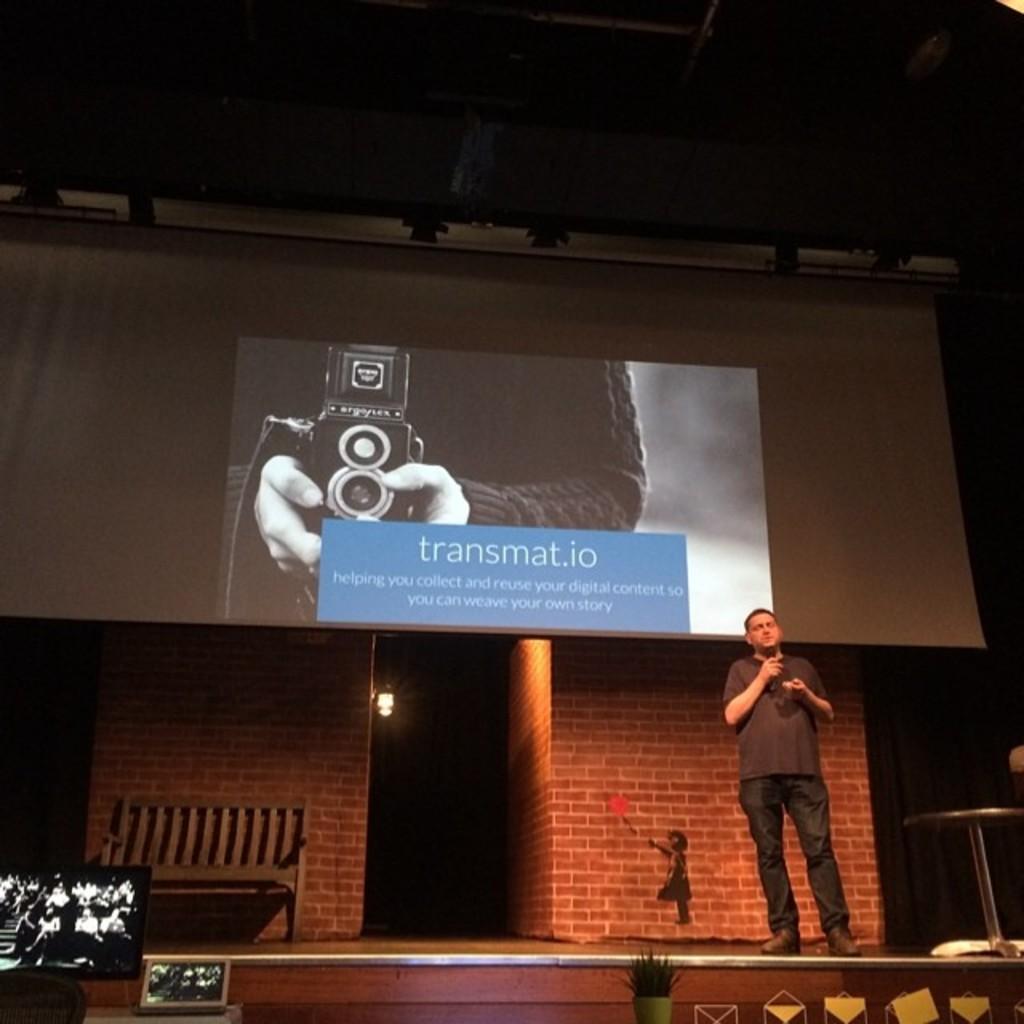Describe this image in one or two sentences. In this image I can see the stage, a screen, a person standing on the stage holding microphone in his hand. In the background I can see the wall, a light, a huge screen and the ceiling. 